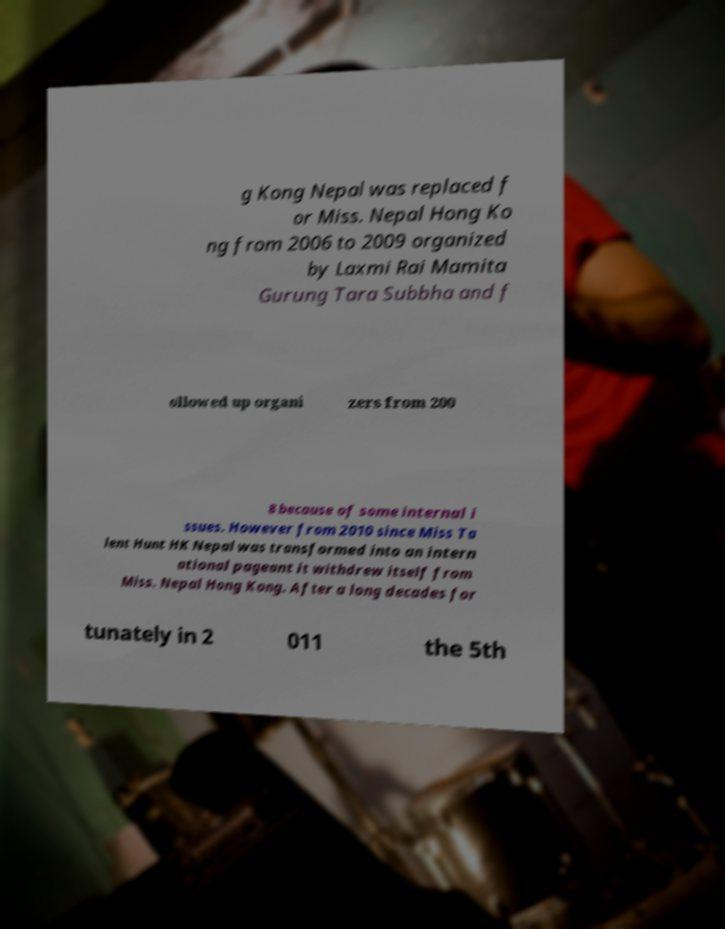There's text embedded in this image that I need extracted. Can you transcribe it verbatim? g Kong Nepal was replaced f or Miss. Nepal Hong Ko ng from 2006 to 2009 organized by Laxmi Rai Mamita Gurung Tara Subbha and f ollowed up organi zers from 200 8 because of some internal i ssues. However from 2010 since Miss Ta lent Hunt HK Nepal was transformed into an intern ational pageant it withdrew itself from Miss. Nepal Hong Kong. After a long decades for tunately in 2 011 the 5th 